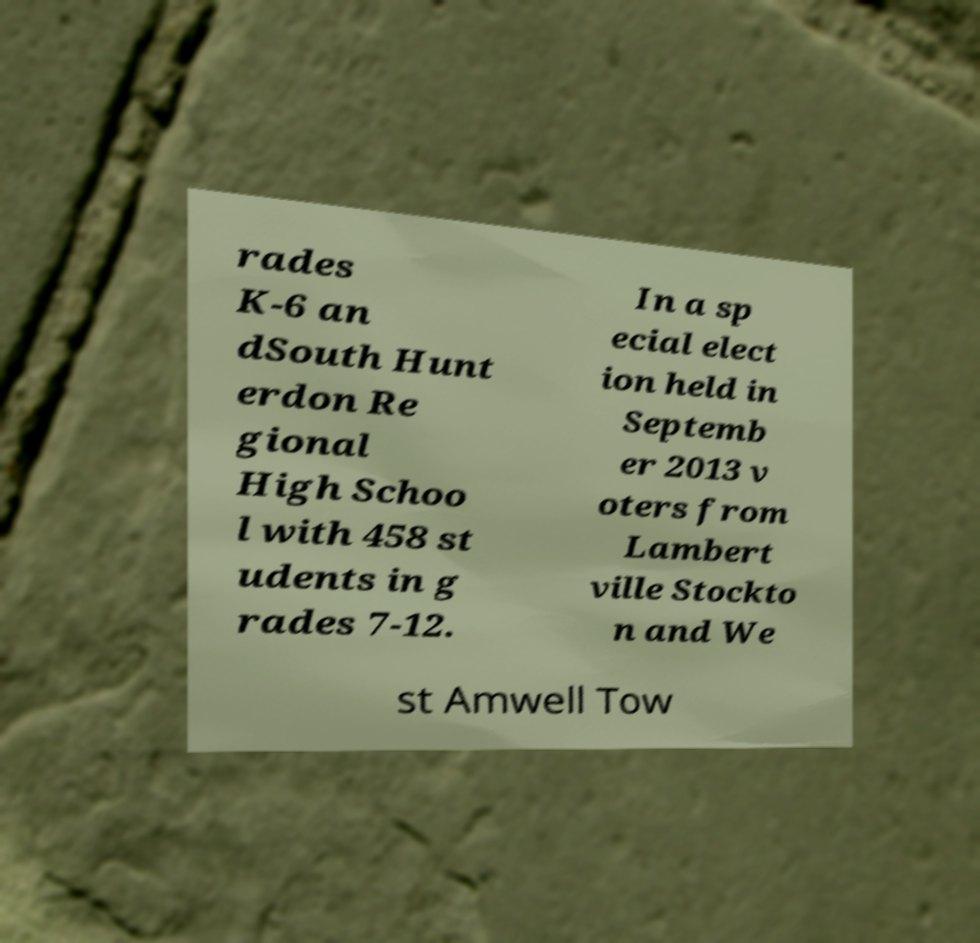Can you accurately transcribe the text from the provided image for me? rades K-6 an dSouth Hunt erdon Re gional High Schoo l with 458 st udents in g rades 7-12. In a sp ecial elect ion held in Septemb er 2013 v oters from Lambert ville Stockto n and We st Amwell Tow 